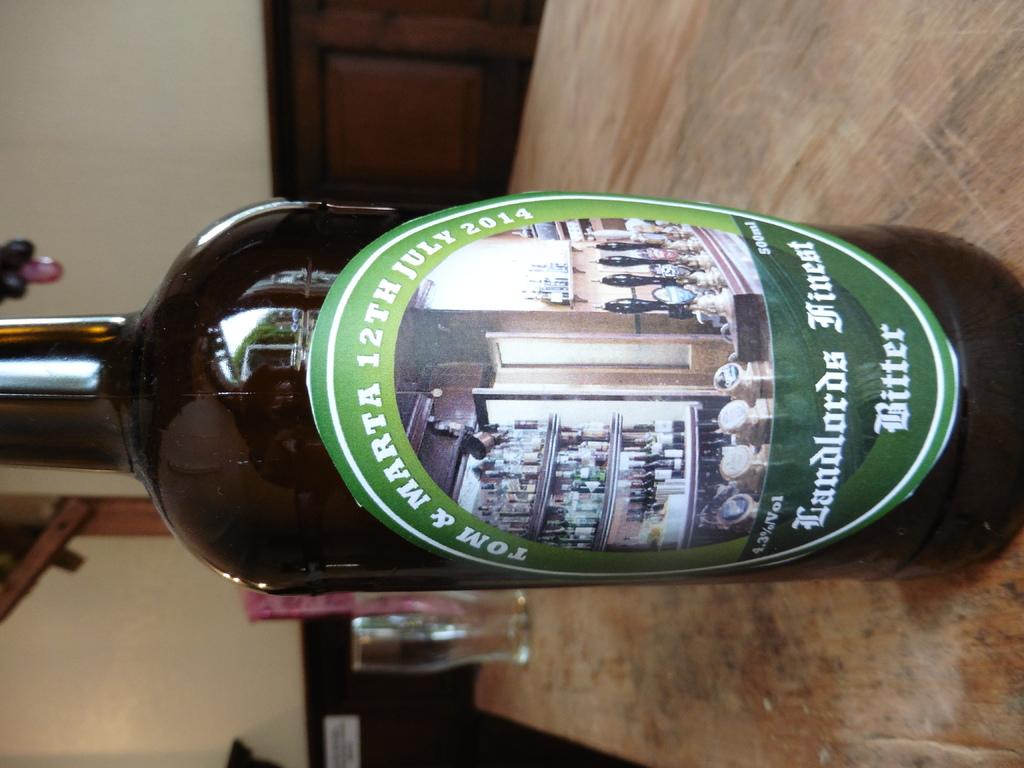<image>
Summarize the visual content of the image. a bottle of Tom and Marta bitter is on the table 